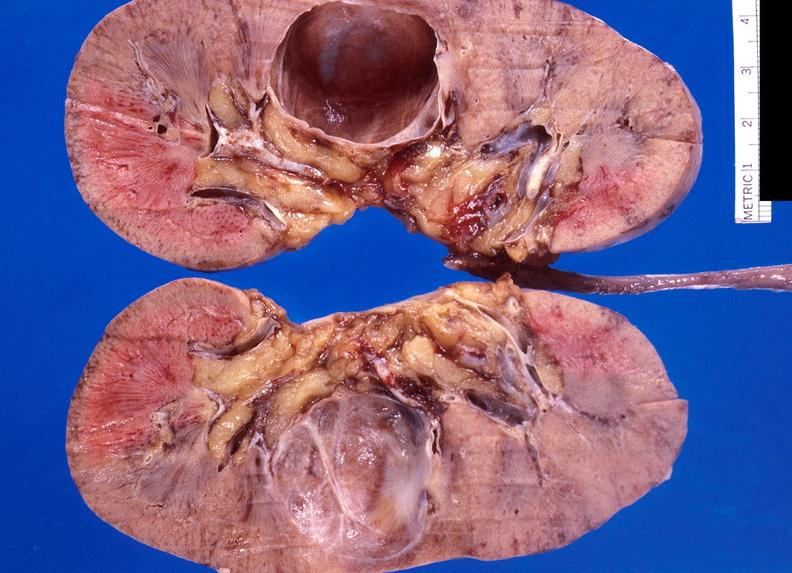does this image show renal cyst?
Answer the question using a single word or phrase. Yes 